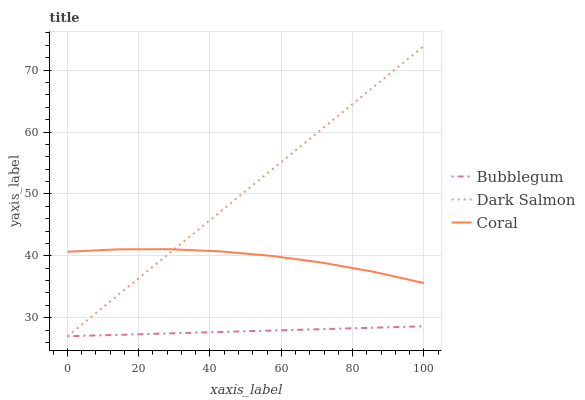Does Dark Salmon have the minimum area under the curve?
Answer yes or no. No. Does Bubblegum have the maximum area under the curve?
Answer yes or no. No. Is Dark Salmon the smoothest?
Answer yes or no. No. Is Dark Salmon the roughest?
Answer yes or no. No. Does Bubblegum have the highest value?
Answer yes or no. No. Is Bubblegum less than Coral?
Answer yes or no. Yes. Is Coral greater than Bubblegum?
Answer yes or no. Yes. Does Bubblegum intersect Coral?
Answer yes or no. No. 